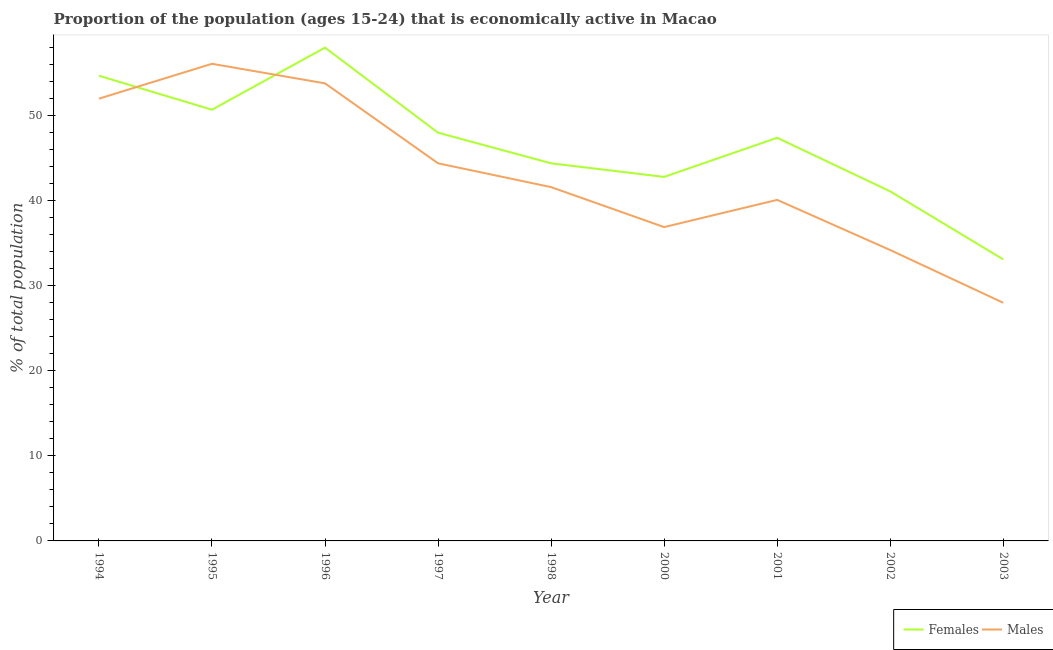How many different coloured lines are there?
Offer a very short reply. 2. Is the number of lines equal to the number of legend labels?
Give a very brief answer. Yes. Across all years, what is the maximum percentage of economically active male population?
Your answer should be very brief. 56.1. Across all years, what is the minimum percentage of economically active female population?
Make the answer very short. 33.1. In which year was the percentage of economically active female population maximum?
Your response must be concise. 1996. What is the total percentage of economically active male population in the graph?
Your answer should be very brief. 387.1. What is the difference between the percentage of economically active female population in 1994 and that in 2000?
Your answer should be compact. 11.9. What is the difference between the percentage of economically active female population in 2001 and the percentage of economically active male population in 2002?
Provide a short and direct response. 13.2. What is the average percentage of economically active female population per year?
Your response must be concise. 46.69. In the year 2002, what is the difference between the percentage of economically active male population and percentage of economically active female population?
Keep it short and to the point. -6.9. What is the ratio of the percentage of economically active male population in 1994 to that in 2002?
Your response must be concise. 1.52. Is the difference between the percentage of economically active female population in 1996 and 2000 greater than the difference between the percentage of economically active male population in 1996 and 2000?
Ensure brevity in your answer.  No. What is the difference between the highest and the second highest percentage of economically active female population?
Your answer should be compact. 3.3. What is the difference between the highest and the lowest percentage of economically active male population?
Offer a terse response. 28.1. In how many years, is the percentage of economically active male population greater than the average percentage of economically active male population taken over all years?
Offer a very short reply. 4. Is the percentage of economically active male population strictly less than the percentage of economically active female population over the years?
Provide a short and direct response. No. How many years are there in the graph?
Give a very brief answer. 9. Are the values on the major ticks of Y-axis written in scientific E-notation?
Your answer should be very brief. No. Does the graph contain any zero values?
Keep it short and to the point. No. Does the graph contain grids?
Offer a very short reply. No. Where does the legend appear in the graph?
Your answer should be compact. Bottom right. What is the title of the graph?
Ensure brevity in your answer.  Proportion of the population (ages 15-24) that is economically active in Macao. What is the label or title of the X-axis?
Give a very brief answer. Year. What is the label or title of the Y-axis?
Keep it short and to the point. % of total population. What is the % of total population of Females in 1994?
Your answer should be very brief. 54.7. What is the % of total population of Females in 1995?
Provide a short and direct response. 50.7. What is the % of total population in Males in 1995?
Provide a short and direct response. 56.1. What is the % of total population of Males in 1996?
Keep it short and to the point. 53.8. What is the % of total population in Females in 1997?
Keep it short and to the point. 48. What is the % of total population of Males in 1997?
Make the answer very short. 44.4. What is the % of total population in Females in 1998?
Give a very brief answer. 44.4. What is the % of total population in Males in 1998?
Give a very brief answer. 41.6. What is the % of total population of Females in 2000?
Keep it short and to the point. 42.8. What is the % of total population of Males in 2000?
Offer a terse response. 36.9. What is the % of total population of Females in 2001?
Keep it short and to the point. 47.4. What is the % of total population in Males in 2001?
Make the answer very short. 40.1. What is the % of total population of Females in 2002?
Provide a short and direct response. 41.1. What is the % of total population of Males in 2002?
Your response must be concise. 34.2. What is the % of total population in Females in 2003?
Provide a short and direct response. 33.1. What is the % of total population in Males in 2003?
Make the answer very short. 28. Across all years, what is the maximum % of total population in Females?
Provide a short and direct response. 58. Across all years, what is the maximum % of total population in Males?
Provide a succinct answer. 56.1. Across all years, what is the minimum % of total population in Females?
Ensure brevity in your answer.  33.1. Across all years, what is the minimum % of total population in Males?
Ensure brevity in your answer.  28. What is the total % of total population of Females in the graph?
Keep it short and to the point. 420.2. What is the total % of total population in Males in the graph?
Your answer should be very brief. 387.1. What is the difference between the % of total population of Females in 1994 and that in 1995?
Offer a very short reply. 4. What is the difference between the % of total population of Males in 1994 and that in 1996?
Your response must be concise. -1.8. What is the difference between the % of total population in Females in 1994 and that in 1998?
Your answer should be very brief. 10.3. What is the difference between the % of total population in Males in 1994 and that in 1998?
Your answer should be very brief. 10.4. What is the difference between the % of total population in Females in 1994 and that in 2000?
Your answer should be compact. 11.9. What is the difference between the % of total population of Males in 1994 and that in 2000?
Your answer should be very brief. 15.1. What is the difference between the % of total population in Females in 1994 and that in 2001?
Your answer should be compact. 7.3. What is the difference between the % of total population in Females in 1994 and that in 2002?
Ensure brevity in your answer.  13.6. What is the difference between the % of total population of Females in 1994 and that in 2003?
Ensure brevity in your answer.  21.6. What is the difference between the % of total population in Males in 1994 and that in 2003?
Provide a succinct answer. 24. What is the difference between the % of total population of Males in 1995 and that in 1997?
Your response must be concise. 11.7. What is the difference between the % of total population of Females in 1995 and that in 1998?
Your answer should be very brief. 6.3. What is the difference between the % of total population in Males in 1995 and that in 2000?
Make the answer very short. 19.2. What is the difference between the % of total population in Males in 1995 and that in 2002?
Keep it short and to the point. 21.9. What is the difference between the % of total population of Males in 1995 and that in 2003?
Offer a terse response. 28.1. What is the difference between the % of total population of Females in 1996 and that in 1997?
Offer a very short reply. 10. What is the difference between the % of total population in Males in 1996 and that in 1997?
Provide a succinct answer. 9.4. What is the difference between the % of total population of Males in 1996 and that in 2000?
Provide a succinct answer. 16.9. What is the difference between the % of total population of Males in 1996 and that in 2001?
Make the answer very short. 13.7. What is the difference between the % of total population of Males in 1996 and that in 2002?
Your answer should be very brief. 19.6. What is the difference between the % of total population of Females in 1996 and that in 2003?
Your answer should be compact. 24.9. What is the difference between the % of total population of Males in 1996 and that in 2003?
Ensure brevity in your answer.  25.8. What is the difference between the % of total population of Females in 1997 and that in 1998?
Keep it short and to the point. 3.6. What is the difference between the % of total population in Males in 1997 and that in 1998?
Provide a short and direct response. 2.8. What is the difference between the % of total population of Females in 1997 and that in 2001?
Your answer should be compact. 0.6. What is the difference between the % of total population in Males in 1997 and that in 2001?
Ensure brevity in your answer.  4.3. What is the difference between the % of total population of Males in 1997 and that in 2002?
Your answer should be compact. 10.2. What is the difference between the % of total population in Females in 1997 and that in 2003?
Your response must be concise. 14.9. What is the difference between the % of total population of Males in 1998 and that in 2001?
Your response must be concise. 1.5. What is the difference between the % of total population in Females in 1998 and that in 2002?
Make the answer very short. 3.3. What is the difference between the % of total population of Males in 1998 and that in 2002?
Make the answer very short. 7.4. What is the difference between the % of total population of Females in 1998 and that in 2003?
Your response must be concise. 11.3. What is the difference between the % of total population in Males in 1998 and that in 2003?
Ensure brevity in your answer.  13.6. What is the difference between the % of total population in Females in 2000 and that in 2001?
Your response must be concise. -4.6. What is the difference between the % of total population in Females in 2000 and that in 2003?
Ensure brevity in your answer.  9.7. What is the difference between the % of total population of Females in 2001 and that in 2002?
Keep it short and to the point. 6.3. What is the difference between the % of total population of Females in 2002 and that in 2003?
Your response must be concise. 8. What is the difference between the % of total population in Males in 2002 and that in 2003?
Keep it short and to the point. 6.2. What is the difference between the % of total population of Females in 1994 and the % of total population of Males in 1995?
Ensure brevity in your answer.  -1.4. What is the difference between the % of total population in Females in 1994 and the % of total population in Males in 1997?
Your answer should be very brief. 10.3. What is the difference between the % of total population of Females in 1994 and the % of total population of Males in 2000?
Your answer should be compact. 17.8. What is the difference between the % of total population in Females in 1994 and the % of total population in Males in 2002?
Make the answer very short. 20.5. What is the difference between the % of total population of Females in 1994 and the % of total population of Males in 2003?
Keep it short and to the point. 26.7. What is the difference between the % of total population in Females in 1995 and the % of total population in Males in 1996?
Ensure brevity in your answer.  -3.1. What is the difference between the % of total population of Females in 1995 and the % of total population of Males in 1998?
Provide a succinct answer. 9.1. What is the difference between the % of total population of Females in 1995 and the % of total population of Males in 2002?
Give a very brief answer. 16.5. What is the difference between the % of total population of Females in 1995 and the % of total population of Males in 2003?
Your answer should be compact. 22.7. What is the difference between the % of total population in Females in 1996 and the % of total population in Males in 2000?
Make the answer very short. 21.1. What is the difference between the % of total population in Females in 1996 and the % of total population in Males in 2002?
Make the answer very short. 23.8. What is the difference between the % of total population of Females in 1996 and the % of total population of Males in 2003?
Your answer should be compact. 30. What is the difference between the % of total population of Females in 1997 and the % of total population of Males in 1998?
Your answer should be compact. 6.4. What is the difference between the % of total population of Females in 1997 and the % of total population of Males in 2000?
Your answer should be compact. 11.1. What is the difference between the % of total population of Females in 1997 and the % of total population of Males in 2001?
Your answer should be compact. 7.9. What is the difference between the % of total population of Females in 1997 and the % of total population of Males in 2003?
Offer a terse response. 20. What is the difference between the % of total population in Females in 1998 and the % of total population in Males in 2000?
Offer a terse response. 7.5. What is the difference between the % of total population of Females in 1998 and the % of total population of Males in 2001?
Provide a short and direct response. 4.3. What is the difference between the % of total population of Females in 1998 and the % of total population of Males in 2002?
Provide a short and direct response. 10.2. What is the difference between the % of total population of Females in 2001 and the % of total population of Males in 2002?
Keep it short and to the point. 13.2. What is the average % of total population of Females per year?
Keep it short and to the point. 46.69. What is the average % of total population in Males per year?
Provide a succinct answer. 43.01. In the year 1994, what is the difference between the % of total population in Females and % of total population in Males?
Your response must be concise. 2.7. In the year 2001, what is the difference between the % of total population of Females and % of total population of Males?
Your answer should be very brief. 7.3. In the year 2002, what is the difference between the % of total population of Females and % of total population of Males?
Make the answer very short. 6.9. What is the ratio of the % of total population in Females in 1994 to that in 1995?
Make the answer very short. 1.08. What is the ratio of the % of total population in Males in 1994 to that in 1995?
Give a very brief answer. 0.93. What is the ratio of the % of total population in Females in 1994 to that in 1996?
Offer a very short reply. 0.94. What is the ratio of the % of total population of Males in 1994 to that in 1996?
Your response must be concise. 0.97. What is the ratio of the % of total population in Females in 1994 to that in 1997?
Ensure brevity in your answer.  1.14. What is the ratio of the % of total population of Males in 1994 to that in 1997?
Make the answer very short. 1.17. What is the ratio of the % of total population of Females in 1994 to that in 1998?
Offer a very short reply. 1.23. What is the ratio of the % of total population in Females in 1994 to that in 2000?
Offer a terse response. 1.28. What is the ratio of the % of total population in Males in 1994 to that in 2000?
Make the answer very short. 1.41. What is the ratio of the % of total population of Females in 1994 to that in 2001?
Ensure brevity in your answer.  1.15. What is the ratio of the % of total population in Males in 1994 to that in 2001?
Ensure brevity in your answer.  1.3. What is the ratio of the % of total population in Females in 1994 to that in 2002?
Provide a short and direct response. 1.33. What is the ratio of the % of total population of Males in 1994 to that in 2002?
Your answer should be compact. 1.52. What is the ratio of the % of total population of Females in 1994 to that in 2003?
Offer a terse response. 1.65. What is the ratio of the % of total population in Males in 1994 to that in 2003?
Your response must be concise. 1.86. What is the ratio of the % of total population in Females in 1995 to that in 1996?
Offer a very short reply. 0.87. What is the ratio of the % of total population of Males in 1995 to that in 1996?
Keep it short and to the point. 1.04. What is the ratio of the % of total population of Females in 1995 to that in 1997?
Keep it short and to the point. 1.06. What is the ratio of the % of total population of Males in 1995 to that in 1997?
Provide a short and direct response. 1.26. What is the ratio of the % of total population of Females in 1995 to that in 1998?
Your answer should be very brief. 1.14. What is the ratio of the % of total population in Males in 1995 to that in 1998?
Make the answer very short. 1.35. What is the ratio of the % of total population of Females in 1995 to that in 2000?
Make the answer very short. 1.18. What is the ratio of the % of total population of Males in 1995 to that in 2000?
Your answer should be very brief. 1.52. What is the ratio of the % of total population of Females in 1995 to that in 2001?
Give a very brief answer. 1.07. What is the ratio of the % of total population of Males in 1995 to that in 2001?
Offer a terse response. 1.4. What is the ratio of the % of total population in Females in 1995 to that in 2002?
Give a very brief answer. 1.23. What is the ratio of the % of total population in Males in 1995 to that in 2002?
Make the answer very short. 1.64. What is the ratio of the % of total population in Females in 1995 to that in 2003?
Ensure brevity in your answer.  1.53. What is the ratio of the % of total population of Males in 1995 to that in 2003?
Your response must be concise. 2. What is the ratio of the % of total population in Females in 1996 to that in 1997?
Make the answer very short. 1.21. What is the ratio of the % of total population in Males in 1996 to that in 1997?
Offer a terse response. 1.21. What is the ratio of the % of total population of Females in 1996 to that in 1998?
Ensure brevity in your answer.  1.31. What is the ratio of the % of total population in Males in 1996 to that in 1998?
Your answer should be very brief. 1.29. What is the ratio of the % of total population in Females in 1996 to that in 2000?
Give a very brief answer. 1.36. What is the ratio of the % of total population in Males in 1996 to that in 2000?
Ensure brevity in your answer.  1.46. What is the ratio of the % of total population in Females in 1996 to that in 2001?
Give a very brief answer. 1.22. What is the ratio of the % of total population of Males in 1996 to that in 2001?
Offer a very short reply. 1.34. What is the ratio of the % of total population of Females in 1996 to that in 2002?
Your response must be concise. 1.41. What is the ratio of the % of total population of Males in 1996 to that in 2002?
Provide a succinct answer. 1.57. What is the ratio of the % of total population in Females in 1996 to that in 2003?
Ensure brevity in your answer.  1.75. What is the ratio of the % of total population in Males in 1996 to that in 2003?
Your answer should be compact. 1.92. What is the ratio of the % of total population in Females in 1997 to that in 1998?
Your response must be concise. 1.08. What is the ratio of the % of total population of Males in 1997 to that in 1998?
Give a very brief answer. 1.07. What is the ratio of the % of total population in Females in 1997 to that in 2000?
Your response must be concise. 1.12. What is the ratio of the % of total population of Males in 1997 to that in 2000?
Your answer should be very brief. 1.2. What is the ratio of the % of total population of Females in 1997 to that in 2001?
Provide a short and direct response. 1.01. What is the ratio of the % of total population of Males in 1997 to that in 2001?
Your response must be concise. 1.11. What is the ratio of the % of total population in Females in 1997 to that in 2002?
Provide a short and direct response. 1.17. What is the ratio of the % of total population in Males in 1997 to that in 2002?
Offer a very short reply. 1.3. What is the ratio of the % of total population of Females in 1997 to that in 2003?
Make the answer very short. 1.45. What is the ratio of the % of total population in Males in 1997 to that in 2003?
Give a very brief answer. 1.59. What is the ratio of the % of total population in Females in 1998 to that in 2000?
Offer a very short reply. 1.04. What is the ratio of the % of total population in Males in 1998 to that in 2000?
Give a very brief answer. 1.13. What is the ratio of the % of total population of Females in 1998 to that in 2001?
Provide a short and direct response. 0.94. What is the ratio of the % of total population of Males in 1998 to that in 2001?
Offer a very short reply. 1.04. What is the ratio of the % of total population of Females in 1998 to that in 2002?
Offer a terse response. 1.08. What is the ratio of the % of total population in Males in 1998 to that in 2002?
Provide a succinct answer. 1.22. What is the ratio of the % of total population of Females in 1998 to that in 2003?
Offer a very short reply. 1.34. What is the ratio of the % of total population in Males in 1998 to that in 2003?
Offer a very short reply. 1.49. What is the ratio of the % of total population of Females in 2000 to that in 2001?
Provide a short and direct response. 0.9. What is the ratio of the % of total population of Males in 2000 to that in 2001?
Ensure brevity in your answer.  0.92. What is the ratio of the % of total population of Females in 2000 to that in 2002?
Your answer should be very brief. 1.04. What is the ratio of the % of total population in Males in 2000 to that in 2002?
Ensure brevity in your answer.  1.08. What is the ratio of the % of total population in Females in 2000 to that in 2003?
Make the answer very short. 1.29. What is the ratio of the % of total population in Males in 2000 to that in 2003?
Offer a very short reply. 1.32. What is the ratio of the % of total population of Females in 2001 to that in 2002?
Ensure brevity in your answer.  1.15. What is the ratio of the % of total population of Males in 2001 to that in 2002?
Keep it short and to the point. 1.17. What is the ratio of the % of total population in Females in 2001 to that in 2003?
Your response must be concise. 1.43. What is the ratio of the % of total population in Males in 2001 to that in 2003?
Offer a terse response. 1.43. What is the ratio of the % of total population in Females in 2002 to that in 2003?
Provide a succinct answer. 1.24. What is the ratio of the % of total population in Males in 2002 to that in 2003?
Give a very brief answer. 1.22. What is the difference between the highest and the second highest % of total population of Males?
Offer a terse response. 2.3. What is the difference between the highest and the lowest % of total population in Females?
Provide a succinct answer. 24.9. What is the difference between the highest and the lowest % of total population in Males?
Make the answer very short. 28.1. 